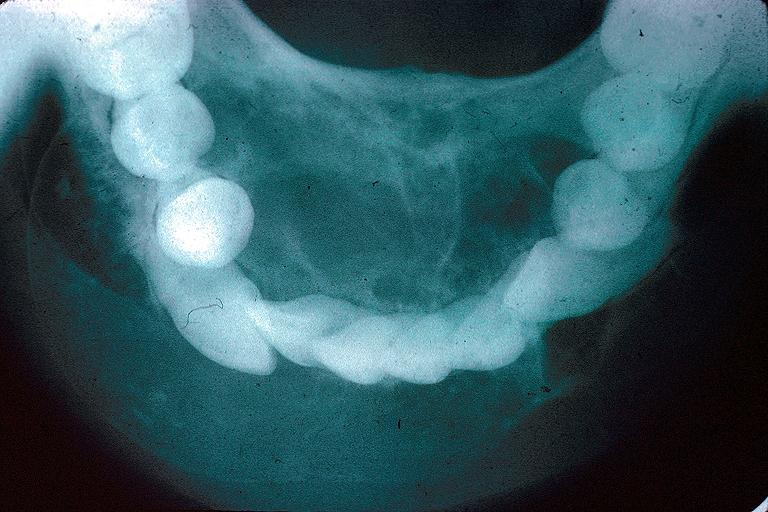does this image show odontogenic myxoma?
Answer the question using a single word or phrase. Yes 